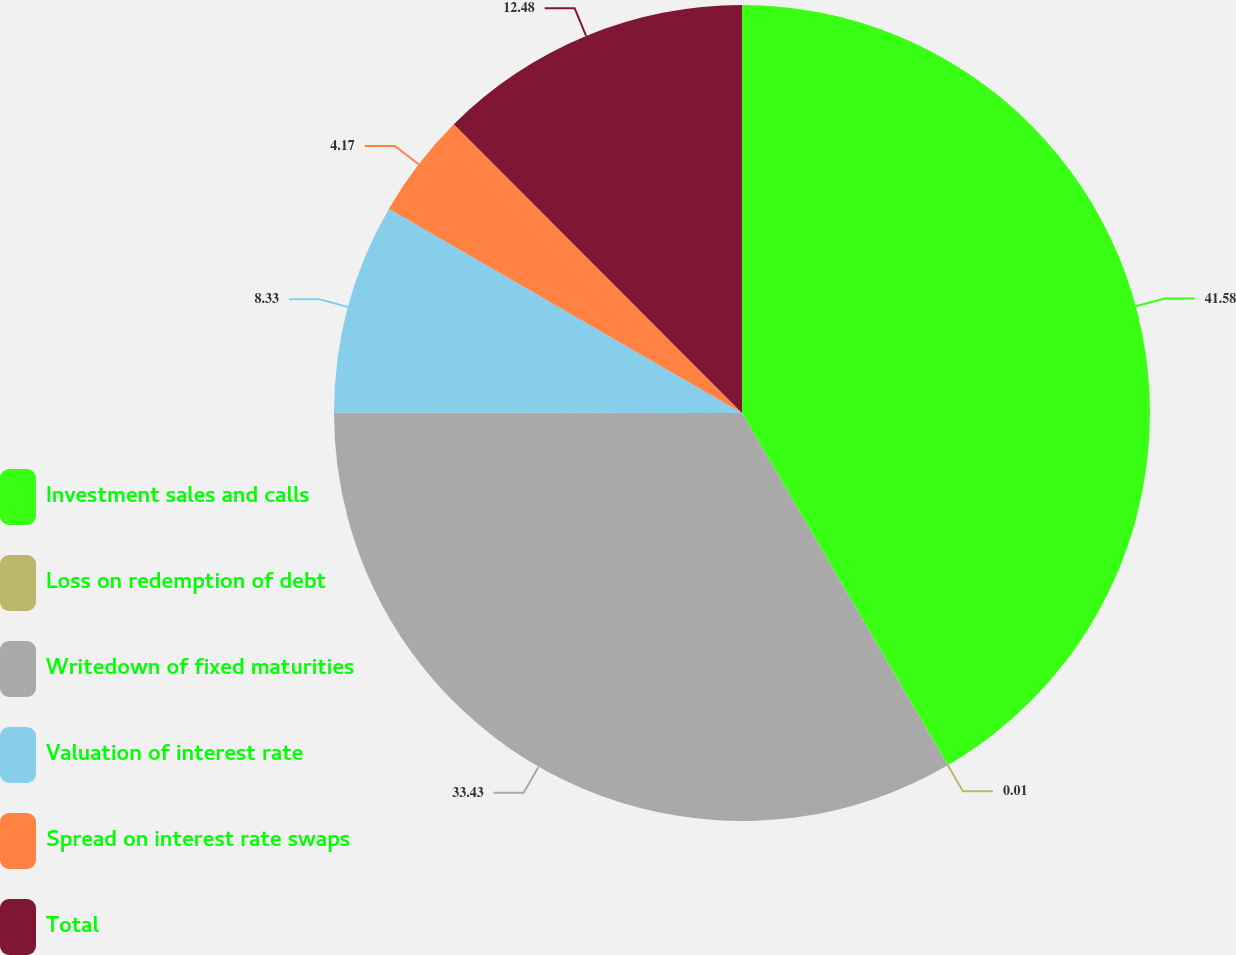Convert chart. <chart><loc_0><loc_0><loc_500><loc_500><pie_chart><fcel>Investment sales and calls<fcel>Loss on redemption of debt<fcel>Writedown of fixed maturities<fcel>Valuation of interest rate<fcel>Spread on interest rate swaps<fcel>Total<nl><fcel>41.58%<fcel>0.01%<fcel>33.43%<fcel>8.33%<fcel>4.17%<fcel>12.48%<nl></chart> 